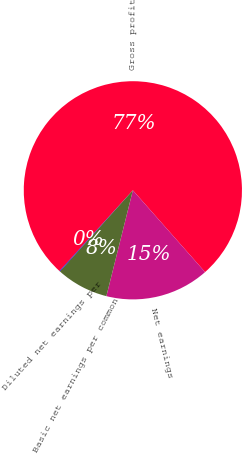Convert chart. <chart><loc_0><loc_0><loc_500><loc_500><pie_chart><fcel>Gross profit<fcel>Net earnings<fcel>Basic net earnings per common<fcel>Diluted net earnings per<nl><fcel>76.75%<fcel>15.42%<fcel>7.75%<fcel>0.09%<nl></chart> 